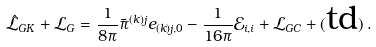Convert formula to latex. <formula><loc_0><loc_0><loc_500><loc_500>\hat { \mathcal { L } } _ { G K } + \mathcal { L } _ { G } = \frac { 1 } { 8 \pi } \bar { \pi } ^ { ( k ) j } e _ { ( k ) j , 0 } - \frac { 1 } { 1 6 \pi } \mathcal { E } _ { i , i } + \mathcal { L } _ { G C } + ( \text {td} ) \, .</formula> 